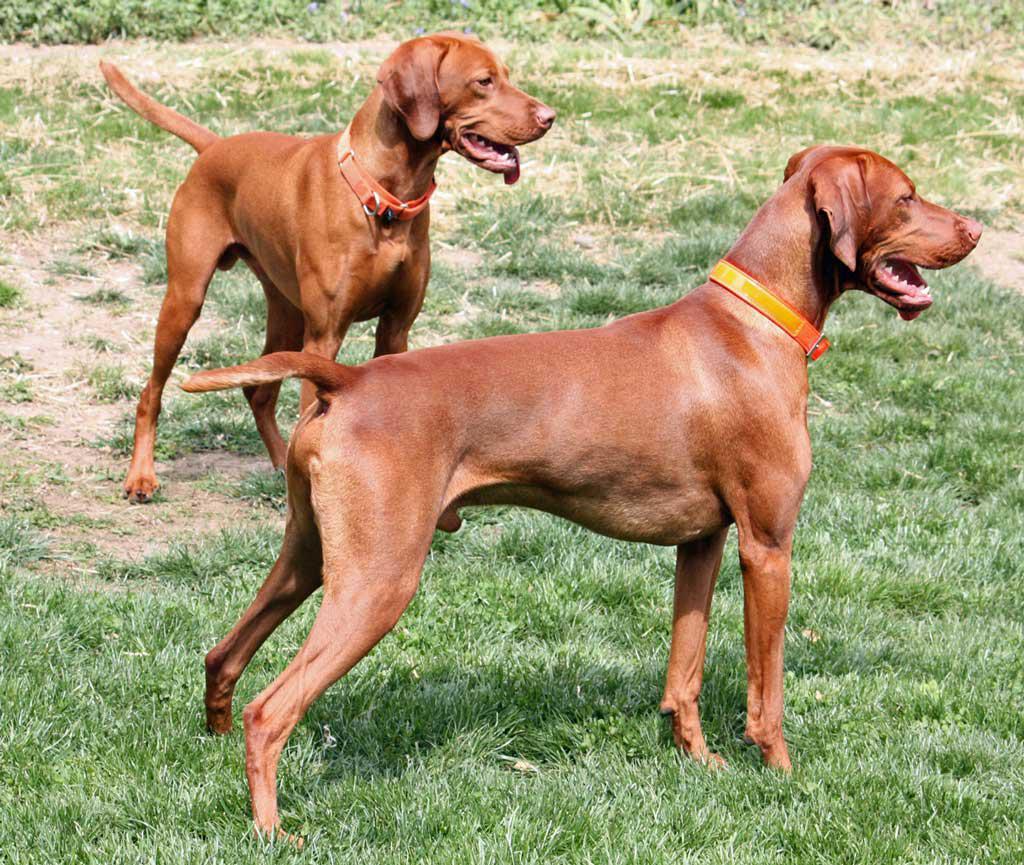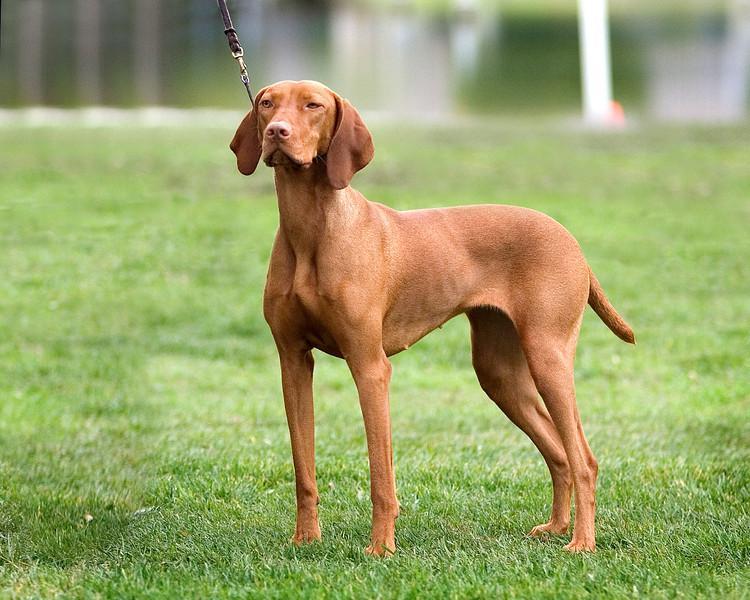The first image is the image on the left, the second image is the image on the right. Examine the images to the left and right. Is the description "Both images contain a dog with their body facing toward the left." accurate? Answer yes or no. No. The first image is the image on the left, the second image is the image on the right. Given the left and right images, does the statement "Both dogs are facing to the left of the images." hold true? Answer yes or no. No. 